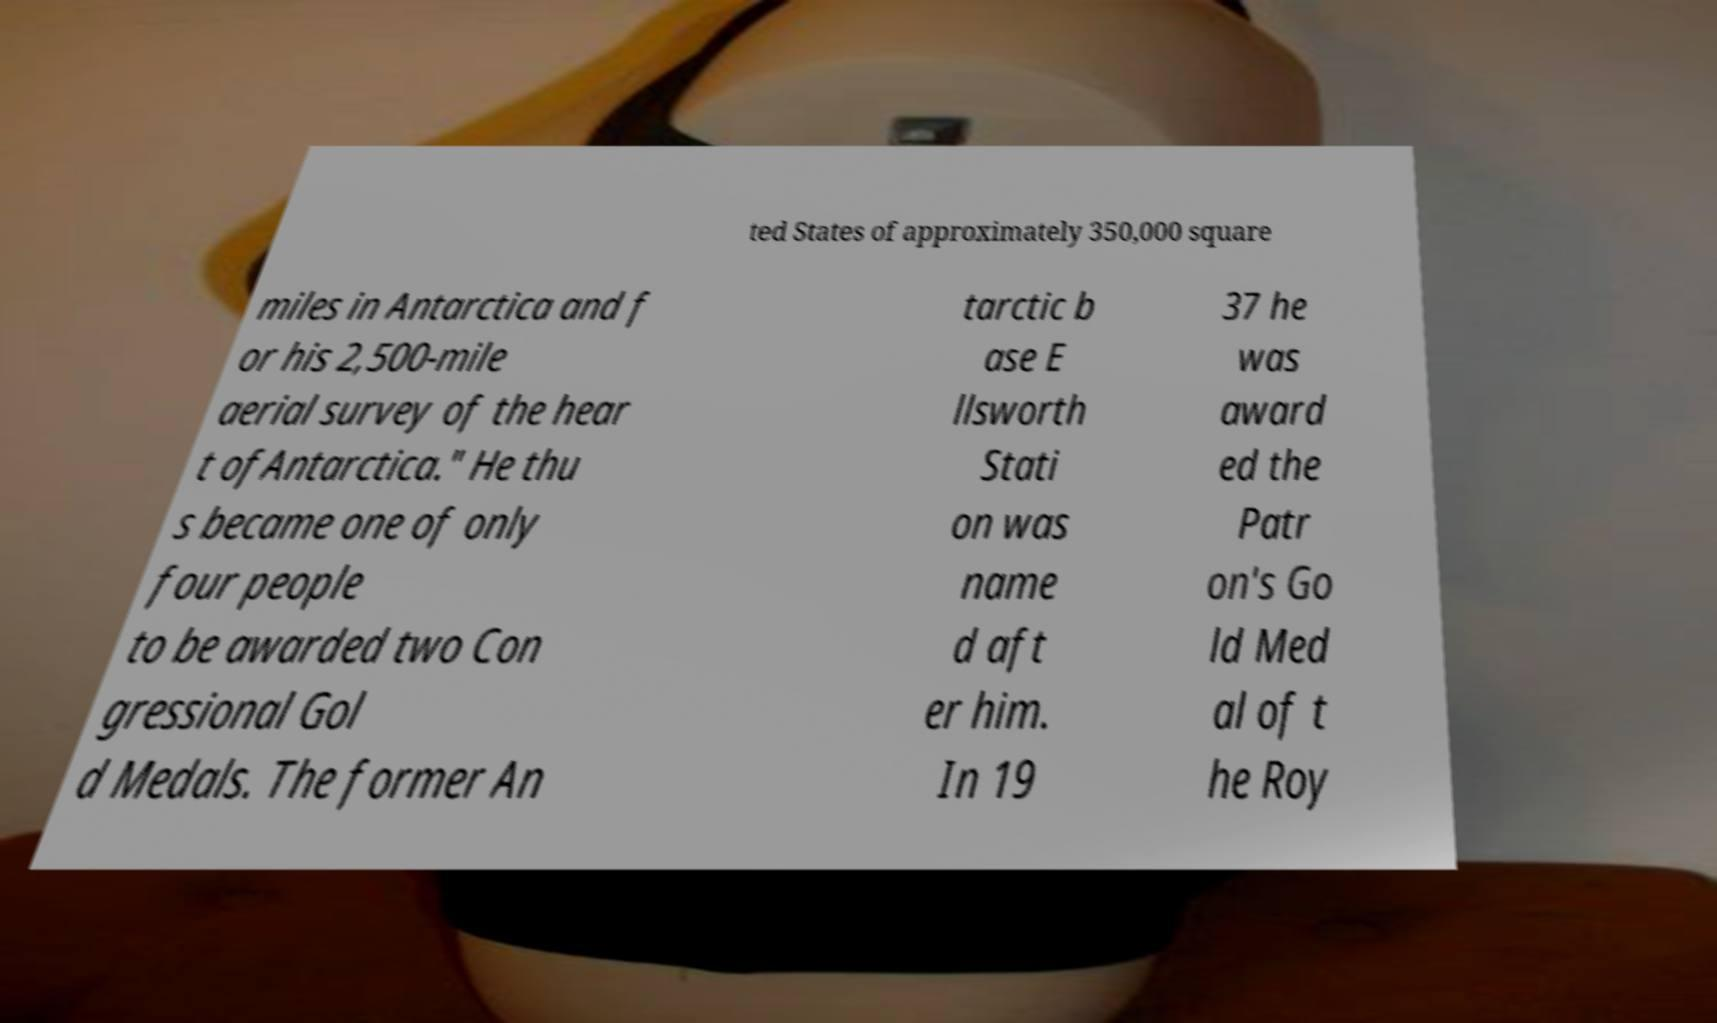There's text embedded in this image that I need extracted. Can you transcribe it verbatim? ted States of approximately 350,000 square miles in Antarctica and f or his 2,500-mile aerial survey of the hear t ofAntarctica." He thu s became one of only four people to be awarded two Con gressional Gol d Medals. The former An tarctic b ase E llsworth Stati on was name d aft er him. In 19 37 he was award ed the Patr on's Go ld Med al of t he Roy 